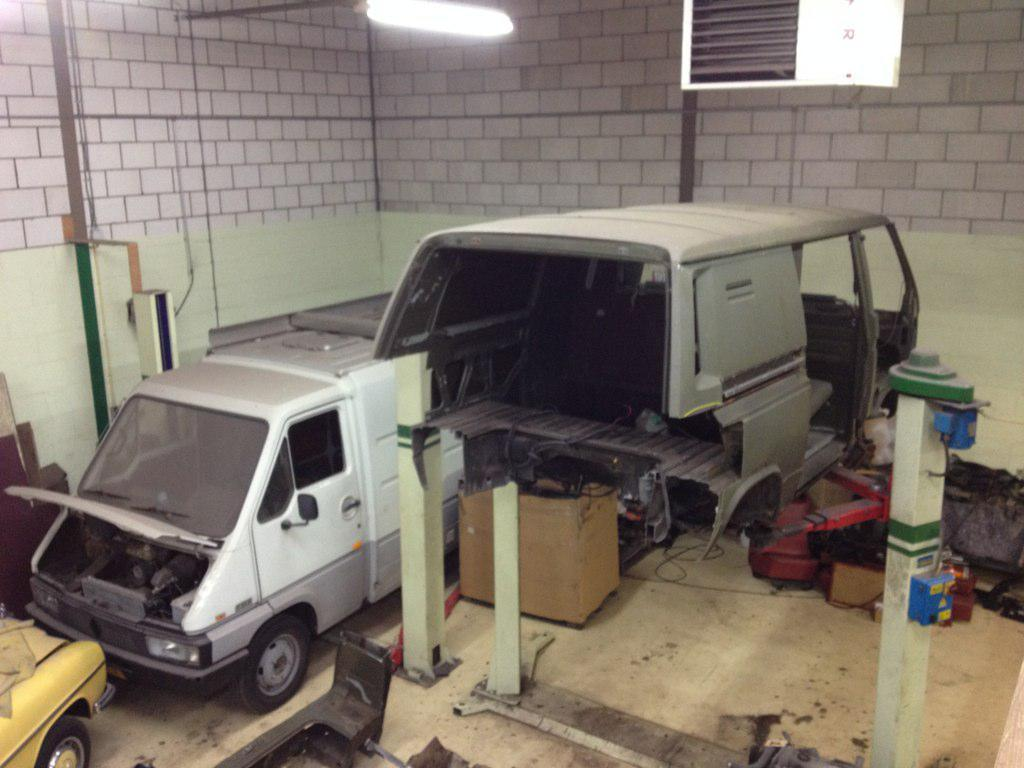What types of objects can be seen in the image? There are vehicles, poles, and unspecified objects in the image. What can be found in the background of the image? There are walls and a light in the background of the image. What type of cheese is hanging from the poles in the image? There is no cheese present in the image; it only features vehicles, poles, unspecified objects, walls, and a light in the background. Can you see any glass objects in the image? The provided facts do not mention any glass objects in the image. 